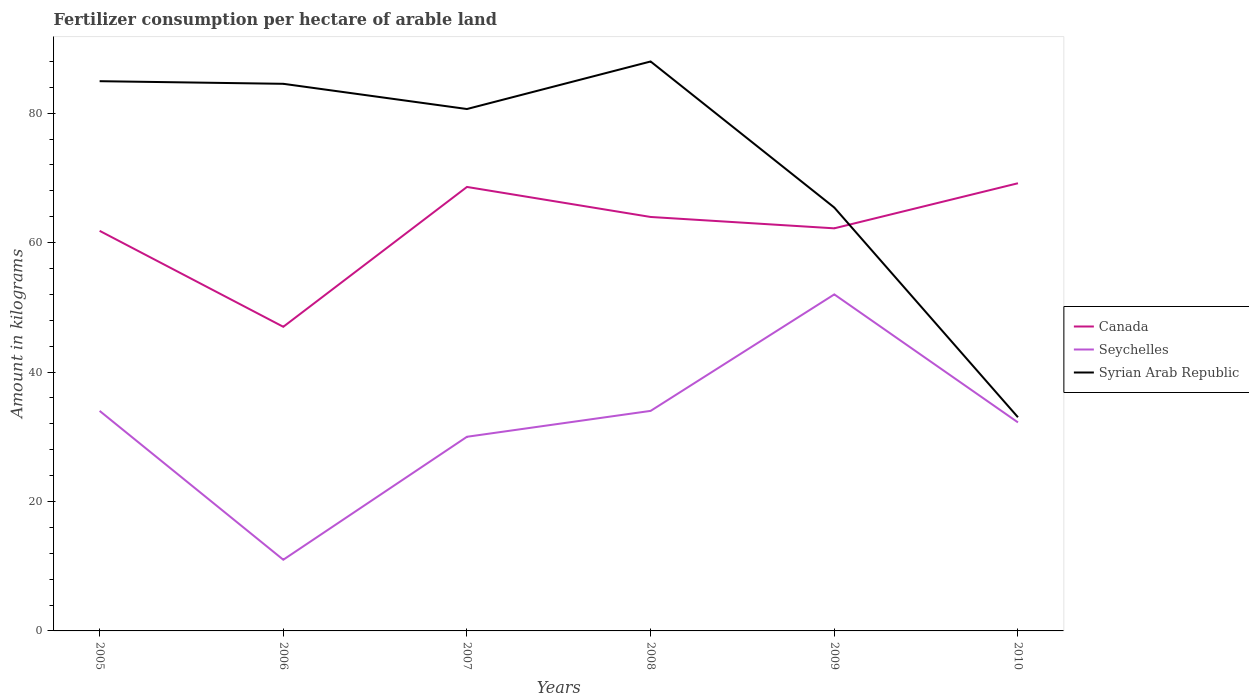How many different coloured lines are there?
Your answer should be very brief. 3. Is the number of lines equal to the number of legend labels?
Give a very brief answer. Yes. Across all years, what is the maximum amount of fertilizer consumption in Syrian Arab Republic?
Ensure brevity in your answer.  33.02. What is the difference between the highest and the second highest amount of fertilizer consumption in Seychelles?
Your answer should be compact. 41. Is the amount of fertilizer consumption in Syrian Arab Republic strictly greater than the amount of fertilizer consumption in Canada over the years?
Your response must be concise. No. How many years are there in the graph?
Ensure brevity in your answer.  6. Does the graph contain any zero values?
Offer a terse response. No. Where does the legend appear in the graph?
Offer a terse response. Center right. How are the legend labels stacked?
Offer a terse response. Vertical. What is the title of the graph?
Ensure brevity in your answer.  Fertilizer consumption per hectare of arable land. What is the label or title of the Y-axis?
Offer a very short reply. Amount in kilograms. What is the Amount in kilograms in Canada in 2005?
Keep it short and to the point. 61.82. What is the Amount in kilograms of Seychelles in 2005?
Offer a very short reply. 34. What is the Amount in kilograms of Syrian Arab Republic in 2005?
Make the answer very short. 84.95. What is the Amount in kilograms in Canada in 2006?
Your response must be concise. 46.99. What is the Amount in kilograms of Seychelles in 2006?
Your response must be concise. 11. What is the Amount in kilograms in Syrian Arab Republic in 2006?
Make the answer very short. 84.54. What is the Amount in kilograms in Canada in 2007?
Your answer should be compact. 68.6. What is the Amount in kilograms of Seychelles in 2007?
Provide a short and direct response. 30. What is the Amount in kilograms in Syrian Arab Republic in 2007?
Provide a short and direct response. 80.65. What is the Amount in kilograms of Canada in 2008?
Your response must be concise. 63.96. What is the Amount in kilograms of Syrian Arab Republic in 2008?
Your response must be concise. 87.99. What is the Amount in kilograms of Canada in 2009?
Your answer should be compact. 62.21. What is the Amount in kilograms of Syrian Arab Republic in 2009?
Make the answer very short. 65.42. What is the Amount in kilograms in Canada in 2010?
Make the answer very short. 69.18. What is the Amount in kilograms in Seychelles in 2010?
Offer a very short reply. 32.22. What is the Amount in kilograms in Syrian Arab Republic in 2010?
Provide a succinct answer. 33.02. Across all years, what is the maximum Amount in kilograms in Canada?
Offer a very short reply. 69.18. Across all years, what is the maximum Amount in kilograms of Syrian Arab Republic?
Give a very brief answer. 87.99. Across all years, what is the minimum Amount in kilograms of Canada?
Ensure brevity in your answer.  46.99. Across all years, what is the minimum Amount in kilograms of Seychelles?
Your answer should be compact. 11. Across all years, what is the minimum Amount in kilograms in Syrian Arab Republic?
Keep it short and to the point. 33.02. What is the total Amount in kilograms in Canada in the graph?
Ensure brevity in your answer.  372.77. What is the total Amount in kilograms in Seychelles in the graph?
Give a very brief answer. 193.22. What is the total Amount in kilograms of Syrian Arab Republic in the graph?
Offer a terse response. 436.56. What is the difference between the Amount in kilograms in Canada in 2005 and that in 2006?
Your answer should be compact. 14.83. What is the difference between the Amount in kilograms of Syrian Arab Republic in 2005 and that in 2006?
Provide a short and direct response. 0.4. What is the difference between the Amount in kilograms in Canada in 2005 and that in 2007?
Offer a very short reply. -6.78. What is the difference between the Amount in kilograms of Syrian Arab Republic in 2005 and that in 2007?
Keep it short and to the point. 4.3. What is the difference between the Amount in kilograms of Canada in 2005 and that in 2008?
Provide a short and direct response. -2.14. What is the difference between the Amount in kilograms in Syrian Arab Republic in 2005 and that in 2008?
Provide a succinct answer. -3.04. What is the difference between the Amount in kilograms in Canada in 2005 and that in 2009?
Make the answer very short. -0.39. What is the difference between the Amount in kilograms in Syrian Arab Republic in 2005 and that in 2009?
Make the answer very short. 19.52. What is the difference between the Amount in kilograms in Canada in 2005 and that in 2010?
Provide a short and direct response. -7.35. What is the difference between the Amount in kilograms of Seychelles in 2005 and that in 2010?
Your answer should be compact. 1.78. What is the difference between the Amount in kilograms of Syrian Arab Republic in 2005 and that in 2010?
Ensure brevity in your answer.  51.93. What is the difference between the Amount in kilograms in Canada in 2006 and that in 2007?
Offer a very short reply. -21.61. What is the difference between the Amount in kilograms of Seychelles in 2006 and that in 2007?
Provide a short and direct response. -19. What is the difference between the Amount in kilograms in Syrian Arab Republic in 2006 and that in 2007?
Your answer should be compact. 3.9. What is the difference between the Amount in kilograms of Canada in 2006 and that in 2008?
Your answer should be very brief. -16.97. What is the difference between the Amount in kilograms in Seychelles in 2006 and that in 2008?
Give a very brief answer. -23. What is the difference between the Amount in kilograms in Syrian Arab Republic in 2006 and that in 2008?
Your answer should be very brief. -3.45. What is the difference between the Amount in kilograms of Canada in 2006 and that in 2009?
Make the answer very short. -15.21. What is the difference between the Amount in kilograms of Seychelles in 2006 and that in 2009?
Make the answer very short. -41. What is the difference between the Amount in kilograms of Syrian Arab Republic in 2006 and that in 2009?
Offer a terse response. 19.12. What is the difference between the Amount in kilograms of Canada in 2006 and that in 2010?
Your answer should be very brief. -22.18. What is the difference between the Amount in kilograms of Seychelles in 2006 and that in 2010?
Your answer should be very brief. -21.22. What is the difference between the Amount in kilograms in Syrian Arab Republic in 2006 and that in 2010?
Your answer should be compact. 51.52. What is the difference between the Amount in kilograms in Canada in 2007 and that in 2008?
Offer a terse response. 4.64. What is the difference between the Amount in kilograms of Seychelles in 2007 and that in 2008?
Offer a very short reply. -4. What is the difference between the Amount in kilograms of Syrian Arab Republic in 2007 and that in 2008?
Provide a succinct answer. -7.34. What is the difference between the Amount in kilograms in Canada in 2007 and that in 2009?
Give a very brief answer. 6.4. What is the difference between the Amount in kilograms of Syrian Arab Republic in 2007 and that in 2009?
Your answer should be very brief. 15.22. What is the difference between the Amount in kilograms in Canada in 2007 and that in 2010?
Give a very brief answer. -0.57. What is the difference between the Amount in kilograms of Seychelles in 2007 and that in 2010?
Keep it short and to the point. -2.22. What is the difference between the Amount in kilograms in Syrian Arab Republic in 2007 and that in 2010?
Your answer should be compact. 47.63. What is the difference between the Amount in kilograms in Canada in 2008 and that in 2009?
Your answer should be compact. 1.76. What is the difference between the Amount in kilograms of Syrian Arab Republic in 2008 and that in 2009?
Offer a terse response. 22.57. What is the difference between the Amount in kilograms of Canada in 2008 and that in 2010?
Give a very brief answer. -5.21. What is the difference between the Amount in kilograms in Seychelles in 2008 and that in 2010?
Offer a very short reply. 1.78. What is the difference between the Amount in kilograms of Syrian Arab Republic in 2008 and that in 2010?
Make the answer very short. 54.97. What is the difference between the Amount in kilograms in Canada in 2009 and that in 2010?
Provide a short and direct response. -6.97. What is the difference between the Amount in kilograms of Seychelles in 2009 and that in 2010?
Ensure brevity in your answer.  19.78. What is the difference between the Amount in kilograms in Syrian Arab Republic in 2009 and that in 2010?
Ensure brevity in your answer.  32.41. What is the difference between the Amount in kilograms in Canada in 2005 and the Amount in kilograms in Seychelles in 2006?
Make the answer very short. 50.82. What is the difference between the Amount in kilograms of Canada in 2005 and the Amount in kilograms of Syrian Arab Republic in 2006?
Your answer should be very brief. -22.72. What is the difference between the Amount in kilograms of Seychelles in 2005 and the Amount in kilograms of Syrian Arab Republic in 2006?
Provide a succinct answer. -50.54. What is the difference between the Amount in kilograms in Canada in 2005 and the Amount in kilograms in Seychelles in 2007?
Keep it short and to the point. 31.82. What is the difference between the Amount in kilograms of Canada in 2005 and the Amount in kilograms of Syrian Arab Republic in 2007?
Provide a short and direct response. -18.82. What is the difference between the Amount in kilograms of Seychelles in 2005 and the Amount in kilograms of Syrian Arab Republic in 2007?
Your response must be concise. -46.65. What is the difference between the Amount in kilograms of Canada in 2005 and the Amount in kilograms of Seychelles in 2008?
Your answer should be very brief. 27.82. What is the difference between the Amount in kilograms of Canada in 2005 and the Amount in kilograms of Syrian Arab Republic in 2008?
Ensure brevity in your answer.  -26.17. What is the difference between the Amount in kilograms in Seychelles in 2005 and the Amount in kilograms in Syrian Arab Republic in 2008?
Provide a succinct answer. -53.99. What is the difference between the Amount in kilograms of Canada in 2005 and the Amount in kilograms of Seychelles in 2009?
Provide a short and direct response. 9.82. What is the difference between the Amount in kilograms in Canada in 2005 and the Amount in kilograms in Syrian Arab Republic in 2009?
Offer a very short reply. -3.6. What is the difference between the Amount in kilograms of Seychelles in 2005 and the Amount in kilograms of Syrian Arab Republic in 2009?
Keep it short and to the point. -31.42. What is the difference between the Amount in kilograms in Canada in 2005 and the Amount in kilograms in Seychelles in 2010?
Ensure brevity in your answer.  29.6. What is the difference between the Amount in kilograms of Canada in 2005 and the Amount in kilograms of Syrian Arab Republic in 2010?
Your answer should be compact. 28.8. What is the difference between the Amount in kilograms in Seychelles in 2005 and the Amount in kilograms in Syrian Arab Republic in 2010?
Your answer should be compact. 0.98. What is the difference between the Amount in kilograms of Canada in 2006 and the Amount in kilograms of Seychelles in 2007?
Your answer should be compact. 16.99. What is the difference between the Amount in kilograms in Canada in 2006 and the Amount in kilograms in Syrian Arab Republic in 2007?
Make the answer very short. -33.65. What is the difference between the Amount in kilograms in Seychelles in 2006 and the Amount in kilograms in Syrian Arab Republic in 2007?
Make the answer very short. -69.65. What is the difference between the Amount in kilograms in Canada in 2006 and the Amount in kilograms in Seychelles in 2008?
Ensure brevity in your answer.  12.99. What is the difference between the Amount in kilograms of Canada in 2006 and the Amount in kilograms of Syrian Arab Republic in 2008?
Give a very brief answer. -41. What is the difference between the Amount in kilograms in Seychelles in 2006 and the Amount in kilograms in Syrian Arab Republic in 2008?
Your answer should be very brief. -76.99. What is the difference between the Amount in kilograms in Canada in 2006 and the Amount in kilograms in Seychelles in 2009?
Make the answer very short. -5.01. What is the difference between the Amount in kilograms in Canada in 2006 and the Amount in kilograms in Syrian Arab Republic in 2009?
Offer a very short reply. -18.43. What is the difference between the Amount in kilograms in Seychelles in 2006 and the Amount in kilograms in Syrian Arab Republic in 2009?
Your response must be concise. -54.42. What is the difference between the Amount in kilograms in Canada in 2006 and the Amount in kilograms in Seychelles in 2010?
Provide a short and direct response. 14.77. What is the difference between the Amount in kilograms of Canada in 2006 and the Amount in kilograms of Syrian Arab Republic in 2010?
Your answer should be very brief. 13.98. What is the difference between the Amount in kilograms in Seychelles in 2006 and the Amount in kilograms in Syrian Arab Republic in 2010?
Ensure brevity in your answer.  -22.02. What is the difference between the Amount in kilograms in Canada in 2007 and the Amount in kilograms in Seychelles in 2008?
Offer a very short reply. 34.6. What is the difference between the Amount in kilograms in Canada in 2007 and the Amount in kilograms in Syrian Arab Republic in 2008?
Provide a succinct answer. -19.39. What is the difference between the Amount in kilograms of Seychelles in 2007 and the Amount in kilograms of Syrian Arab Republic in 2008?
Your response must be concise. -57.99. What is the difference between the Amount in kilograms in Canada in 2007 and the Amount in kilograms in Seychelles in 2009?
Your answer should be very brief. 16.6. What is the difference between the Amount in kilograms of Canada in 2007 and the Amount in kilograms of Syrian Arab Republic in 2009?
Offer a terse response. 3.18. What is the difference between the Amount in kilograms of Seychelles in 2007 and the Amount in kilograms of Syrian Arab Republic in 2009?
Your response must be concise. -35.42. What is the difference between the Amount in kilograms in Canada in 2007 and the Amount in kilograms in Seychelles in 2010?
Make the answer very short. 36.38. What is the difference between the Amount in kilograms in Canada in 2007 and the Amount in kilograms in Syrian Arab Republic in 2010?
Provide a short and direct response. 35.59. What is the difference between the Amount in kilograms of Seychelles in 2007 and the Amount in kilograms of Syrian Arab Republic in 2010?
Your answer should be very brief. -3.02. What is the difference between the Amount in kilograms of Canada in 2008 and the Amount in kilograms of Seychelles in 2009?
Offer a terse response. 11.96. What is the difference between the Amount in kilograms of Canada in 2008 and the Amount in kilograms of Syrian Arab Republic in 2009?
Keep it short and to the point. -1.46. What is the difference between the Amount in kilograms in Seychelles in 2008 and the Amount in kilograms in Syrian Arab Republic in 2009?
Your response must be concise. -31.42. What is the difference between the Amount in kilograms in Canada in 2008 and the Amount in kilograms in Seychelles in 2010?
Provide a succinct answer. 31.74. What is the difference between the Amount in kilograms in Canada in 2008 and the Amount in kilograms in Syrian Arab Republic in 2010?
Offer a very short reply. 30.95. What is the difference between the Amount in kilograms of Seychelles in 2008 and the Amount in kilograms of Syrian Arab Republic in 2010?
Keep it short and to the point. 0.98. What is the difference between the Amount in kilograms of Canada in 2009 and the Amount in kilograms of Seychelles in 2010?
Provide a short and direct response. 29.99. What is the difference between the Amount in kilograms of Canada in 2009 and the Amount in kilograms of Syrian Arab Republic in 2010?
Provide a succinct answer. 29.19. What is the difference between the Amount in kilograms in Seychelles in 2009 and the Amount in kilograms in Syrian Arab Republic in 2010?
Your response must be concise. 18.98. What is the average Amount in kilograms of Canada per year?
Offer a terse response. 62.13. What is the average Amount in kilograms in Seychelles per year?
Give a very brief answer. 32.2. What is the average Amount in kilograms in Syrian Arab Republic per year?
Your response must be concise. 72.76. In the year 2005, what is the difference between the Amount in kilograms in Canada and Amount in kilograms in Seychelles?
Your answer should be very brief. 27.82. In the year 2005, what is the difference between the Amount in kilograms in Canada and Amount in kilograms in Syrian Arab Republic?
Offer a terse response. -23.12. In the year 2005, what is the difference between the Amount in kilograms in Seychelles and Amount in kilograms in Syrian Arab Republic?
Make the answer very short. -50.95. In the year 2006, what is the difference between the Amount in kilograms in Canada and Amount in kilograms in Seychelles?
Offer a very short reply. 35.99. In the year 2006, what is the difference between the Amount in kilograms of Canada and Amount in kilograms of Syrian Arab Republic?
Your answer should be very brief. -37.55. In the year 2006, what is the difference between the Amount in kilograms in Seychelles and Amount in kilograms in Syrian Arab Republic?
Ensure brevity in your answer.  -73.54. In the year 2007, what is the difference between the Amount in kilograms in Canada and Amount in kilograms in Seychelles?
Provide a short and direct response. 38.6. In the year 2007, what is the difference between the Amount in kilograms in Canada and Amount in kilograms in Syrian Arab Republic?
Your response must be concise. -12.04. In the year 2007, what is the difference between the Amount in kilograms in Seychelles and Amount in kilograms in Syrian Arab Republic?
Keep it short and to the point. -50.65. In the year 2008, what is the difference between the Amount in kilograms in Canada and Amount in kilograms in Seychelles?
Your answer should be very brief. 29.96. In the year 2008, what is the difference between the Amount in kilograms in Canada and Amount in kilograms in Syrian Arab Republic?
Provide a short and direct response. -24.03. In the year 2008, what is the difference between the Amount in kilograms in Seychelles and Amount in kilograms in Syrian Arab Republic?
Provide a short and direct response. -53.99. In the year 2009, what is the difference between the Amount in kilograms of Canada and Amount in kilograms of Seychelles?
Provide a succinct answer. 10.21. In the year 2009, what is the difference between the Amount in kilograms in Canada and Amount in kilograms in Syrian Arab Republic?
Offer a very short reply. -3.21. In the year 2009, what is the difference between the Amount in kilograms of Seychelles and Amount in kilograms of Syrian Arab Republic?
Provide a succinct answer. -13.42. In the year 2010, what is the difference between the Amount in kilograms in Canada and Amount in kilograms in Seychelles?
Offer a terse response. 36.95. In the year 2010, what is the difference between the Amount in kilograms in Canada and Amount in kilograms in Syrian Arab Republic?
Offer a terse response. 36.16. In the year 2010, what is the difference between the Amount in kilograms in Seychelles and Amount in kilograms in Syrian Arab Republic?
Keep it short and to the point. -0.79. What is the ratio of the Amount in kilograms in Canada in 2005 to that in 2006?
Your answer should be very brief. 1.32. What is the ratio of the Amount in kilograms in Seychelles in 2005 to that in 2006?
Offer a very short reply. 3.09. What is the ratio of the Amount in kilograms in Syrian Arab Republic in 2005 to that in 2006?
Provide a succinct answer. 1. What is the ratio of the Amount in kilograms of Canada in 2005 to that in 2007?
Make the answer very short. 0.9. What is the ratio of the Amount in kilograms of Seychelles in 2005 to that in 2007?
Ensure brevity in your answer.  1.13. What is the ratio of the Amount in kilograms of Syrian Arab Republic in 2005 to that in 2007?
Offer a terse response. 1.05. What is the ratio of the Amount in kilograms of Canada in 2005 to that in 2008?
Offer a terse response. 0.97. What is the ratio of the Amount in kilograms of Seychelles in 2005 to that in 2008?
Give a very brief answer. 1. What is the ratio of the Amount in kilograms of Syrian Arab Republic in 2005 to that in 2008?
Provide a short and direct response. 0.97. What is the ratio of the Amount in kilograms of Canada in 2005 to that in 2009?
Give a very brief answer. 0.99. What is the ratio of the Amount in kilograms of Seychelles in 2005 to that in 2009?
Provide a short and direct response. 0.65. What is the ratio of the Amount in kilograms of Syrian Arab Republic in 2005 to that in 2009?
Keep it short and to the point. 1.3. What is the ratio of the Amount in kilograms of Canada in 2005 to that in 2010?
Provide a succinct answer. 0.89. What is the ratio of the Amount in kilograms of Seychelles in 2005 to that in 2010?
Keep it short and to the point. 1.06. What is the ratio of the Amount in kilograms of Syrian Arab Republic in 2005 to that in 2010?
Give a very brief answer. 2.57. What is the ratio of the Amount in kilograms in Canada in 2006 to that in 2007?
Provide a short and direct response. 0.69. What is the ratio of the Amount in kilograms of Seychelles in 2006 to that in 2007?
Make the answer very short. 0.37. What is the ratio of the Amount in kilograms in Syrian Arab Republic in 2006 to that in 2007?
Provide a short and direct response. 1.05. What is the ratio of the Amount in kilograms of Canada in 2006 to that in 2008?
Offer a terse response. 0.73. What is the ratio of the Amount in kilograms of Seychelles in 2006 to that in 2008?
Ensure brevity in your answer.  0.32. What is the ratio of the Amount in kilograms of Syrian Arab Republic in 2006 to that in 2008?
Make the answer very short. 0.96. What is the ratio of the Amount in kilograms of Canada in 2006 to that in 2009?
Your answer should be compact. 0.76. What is the ratio of the Amount in kilograms in Seychelles in 2006 to that in 2009?
Provide a succinct answer. 0.21. What is the ratio of the Amount in kilograms of Syrian Arab Republic in 2006 to that in 2009?
Make the answer very short. 1.29. What is the ratio of the Amount in kilograms of Canada in 2006 to that in 2010?
Your answer should be compact. 0.68. What is the ratio of the Amount in kilograms in Seychelles in 2006 to that in 2010?
Your answer should be very brief. 0.34. What is the ratio of the Amount in kilograms in Syrian Arab Republic in 2006 to that in 2010?
Provide a succinct answer. 2.56. What is the ratio of the Amount in kilograms in Canada in 2007 to that in 2008?
Make the answer very short. 1.07. What is the ratio of the Amount in kilograms in Seychelles in 2007 to that in 2008?
Make the answer very short. 0.88. What is the ratio of the Amount in kilograms of Syrian Arab Republic in 2007 to that in 2008?
Your answer should be very brief. 0.92. What is the ratio of the Amount in kilograms in Canada in 2007 to that in 2009?
Provide a short and direct response. 1.1. What is the ratio of the Amount in kilograms in Seychelles in 2007 to that in 2009?
Offer a terse response. 0.58. What is the ratio of the Amount in kilograms of Syrian Arab Republic in 2007 to that in 2009?
Ensure brevity in your answer.  1.23. What is the ratio of the Amount in kilograms of Canada in 2007 to that in 2010?
Ensure brevity in your answer.  0.99. What is the ratio of the Amount in kilograms in Seychelles in 2007 to that in 2010?
Ensure brevity in your answer.  0.93. What is the ratio of the Amount in kilograms of Syrian Arab Republic in 2007 to that in 2010?
Your answer should be compact. 2.44. What is the ratio of the Amount in kilograms in Canada in 2008 to that in 2009?
Keep it short and to the point. 1.03. What is the ratio of the Amount in kilograms in Seychelles in 2008 to that in 2009?
Ensure brevity in your answer.  0.65. What is the ratio of the Amount in kilograms of Syrian Arab Republic in 2008 to that in 2009?
Give a very brief answer. 1.34. What is the ratio of the Amount in kilograms of Canada in 2008 to that in 2010?
Offer a very short reply. 0.92. What is the ratio of the Amount in kilograms of Seychelles in 2008 to that in 2010?
Ensure brevity in your answer.  1.06. What is the ratio of the Amount in kilograms in Syrian Arab Republic in 2008 to that in 2010?
Make the answer very short. 2.67. What is the ratio of the Amount in kilograms of Canada in 2009 to that in 2010?
Make the answer very short. 0.9. What is the ratio of the Amount in kilograms in Seychelles in 2009 to that in 2010?
Ensure brevity in your answer.  1.61. What is the ratio of the Amount in kilograms in Syrian Arab Republic in 2009 to that in 2010?
Your response must be concise. 1.98. What is the difference between the highest and the second highest Amount in kilograms of Canada?
Your response must be concise. 0.57. What is the difference between the highest and the second highest Amount in kilograms of Syrian Arab Republic?
Provide a succinct answer. 3.04. What is the difference between the highest and the lowest Amount in kilograms in Canada?
Ensure brevity in your answer.  22.18. What is the difference between the highest and the lowest Amount in kilograms in Seychelles?
Offer a very short reply. 41. What is the difference between the highest and the lowest Amount in kilograms of Syrian Arab Republic?
Your answer should be compact. 54.97. 